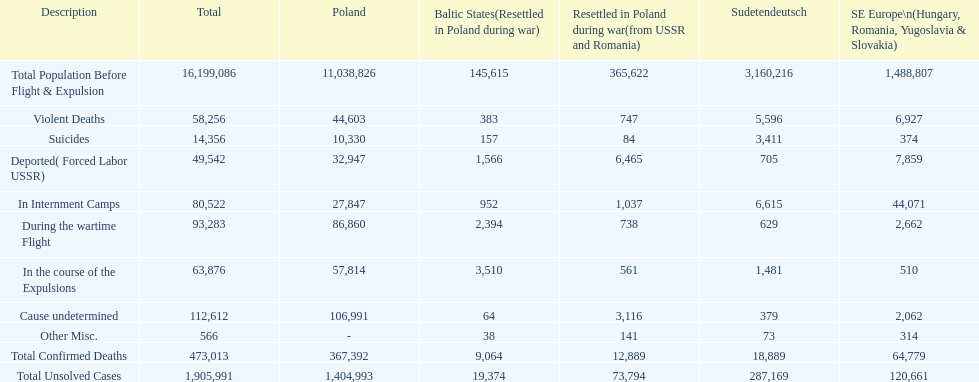Before expulsion occurred, did poland or sudetendeutsch have a larger overall population? Poland. 